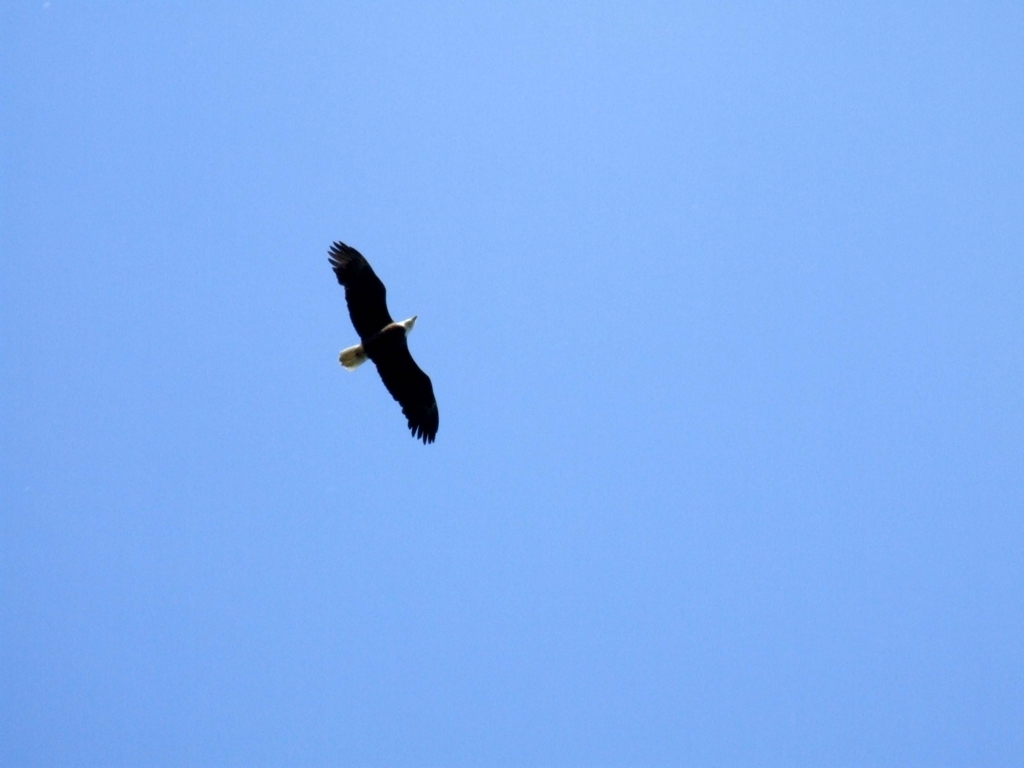What species of bird is shown in this image? The bird in the image appears to be a bald eagle, recognized by its distinct dark brown body and wings with a contrasting white head and tail, as well as its hooked yellow beak. Why might the eagle be flying at that altitude? Bald eagles often soar at high altitudes to scan their territory for prey and to utilize thermal updrafts for energy-efficient flying. They might also be in transit between feeding areas or searching for nesting sites. 